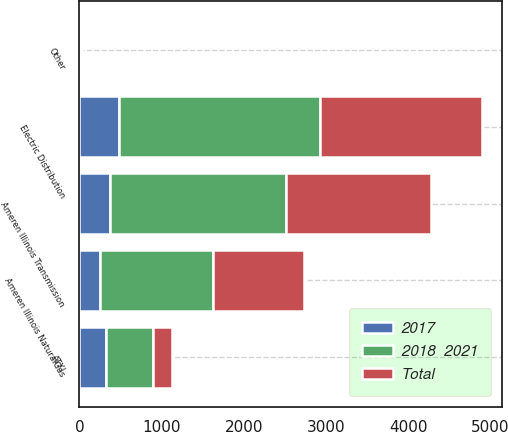Convert chart. <chart><loc_0><loc_0><loc_500><loc_500><stacked_bar_chart><ecel><fcel>Electric Distribution<fcel>Ameren Illinois NaturalGas<fcel>Ameren Illinois Transmission<fcel>ATXI<fcel>Other<nl><fcel>2017<fcel>480<fcel>255<fcel>375<fcel>325<fcel>5<nl><fcel>Total<fcel>1965<fcel>1110<fcel>1760<fcel>240<fcel>10<nl><fcel>2018  2021<fcel>2445<fcel>1365<fcel>2135<fcel>565<fcel>15<nl></chart> 